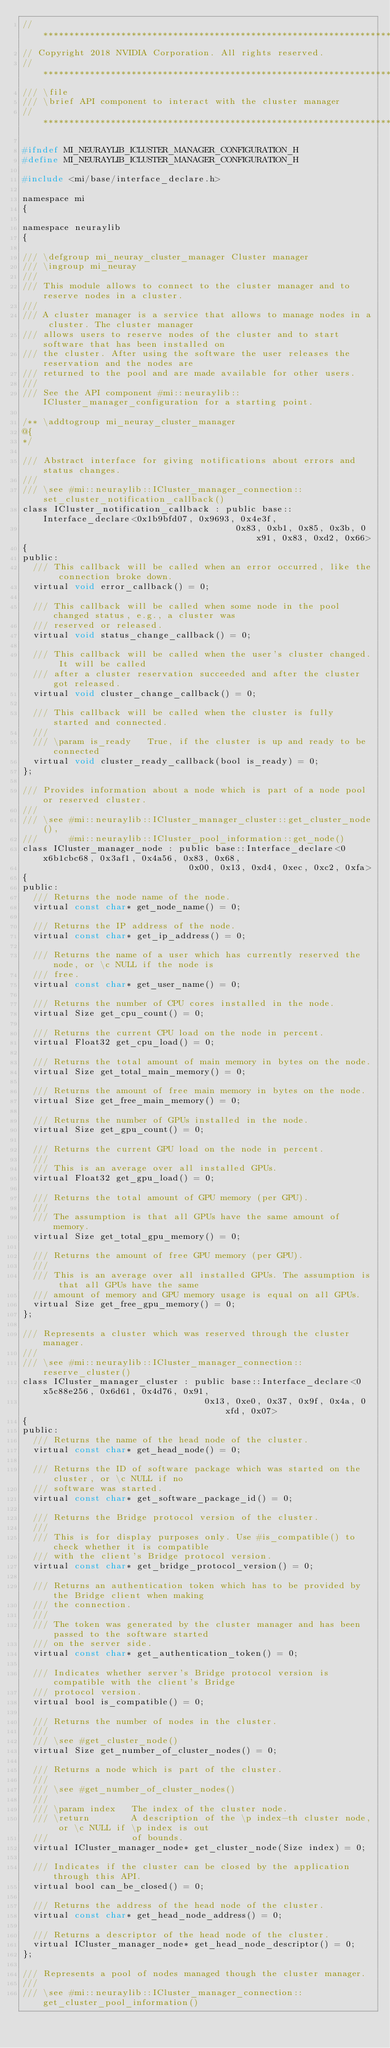Convert code to text. <code><loc_0><loc_0><loc_500><loc_500><_C_>//*****************************************************************************
// Copyright 2018 NVIDIA Corporation. All rights reserved.
//*****************************************************************************
/// \file
/// \brief API component to interact with the cluster manager
//*****************************************************************************

#ifndef MI_NEURAYLIB_ICLUSTER_MANAGER_CONFIGURATION_H
#define MI_NEURAYLIB_ICLUSTER_MANAGER_CONFIGURATION_H

#include <mi/base/interface_declare.h>

namespace mi
{

namespace neuraylib
{

/// \defgroup mi_neuray_cluster_manager Cluster manager
/// \ingroup mi_neuray
///
/// This module allows to connect to the cluster manager and to reserve nodes in a cluster.
///
/// A cluster manager is a service that allows to manage nodes in a cluster. The cluster manager
/// allows users to reserve nodes of the cluster and to start software that has been installed on
/// the cluster. After using the software the user releases the reservation and the nodes are
/// returned to the pool and are made available for other users.
///
/// See the API component #mi::neuraylib::ICluster_manager_configuration for a starting point.

/** \addtogroup mi_neuray_cluster_manager
@{
*/

/// Abstract interface for giving notifications about errors and status changes.
///
/// \see #mi::neuraylib::ICluster_manager_connection::set_cluster_notification_callback()
class ICluster_notification_callback : public base::Interface_declare<0x1b9bfd07, 0x9693, 0x4e3f,
                                         0x83, 0xb1, 0x85, 0x3b, 0x91, 0x83, 0xd2, 0x66>
{
public:
  /// This callback will be called when an error occurred, like the connection broke down.
  virtual void error_callback() = 0;

  /// This callback will be called when some node in the pool changed status, e.g., a cluster was
  /// reserved or released.
  virtual void status_change_callback() = 0;

  /// This callback will be called when the user's cluster changed. It will be called
  /// after a cluster reservation succeeded and after the cluster got released.
  virtual void cluster_change_callback() = 0;

  /// This callback will be called when the cluster is fully started and connected.
  ///
  /// \param is_ready   True, if the cluster is up and ready to be connected
  virtual void cluster_ready_callback(bool is_ready) = 0;
};

/// Provides information about a node which is part of a node pool or reserved cluster.
///
/// \see #mi::neuraylib::ICluster_manager_cluster::get_cluster_node(),
///      #mi::neuraylib::ICluster_pool_information::get_node()
class ICluster_manager_node : public base::Interface_declare<0x6b1cbc68, 0x3af1, 0x4a56, 0x83, 0x68,
                                0x00, 0x13, 0xd4, 0xec, 0xc2, 0xfa>
{
public:
  /// Returns the node name of the node.
  virtual const char* get_node_name() = 0;

  /// Returns the IP address of the node.
  virtual const char* get_ip_address() = 0;

  /// Returns the name of a user which has currently reserved the node, or \c NULL if the node is
  /// free.
  virtual const char* get_user_name() = 0;

  /// Returns the number of CPU cores installed in the node.
  virtual Size get_cpu_count() = 0;

  /// Returns the current CPU load on the node in percent.
  virtual Float32 get_cpu_load() = 0;

  /// Returns the total amount of main memory in bytes on the node.
  virtual Size get_total_main_memory() = 0;

  /// Returns the amount of free main memory in bytes on the node.
  virtual Size get_free_main_memory() = 0;

  /// Returns the number of GPUs installed in the node.
  virtual Size get_gpu_count() = 0;

  /// Returns the current GPU load on the node in percent.
  ///
  /// This is an average over all installed GPUs.
  virtual Float32 get_gpu_load() = 0;

  /// Returns the total amount of GPU memory (per GPU).
  ///
  /// The assumption is that all GPUs have the same amount of memory.
  virtual Size get_total_gpu_memory() = 0;

  /// Returns the amount of free GPU memory (per GPU).
  ///
  /// This is an average over all installed GPUs. The assumption is that all GPUs have the same
  /// amount of memory and GPU memory usage is equal on all GPUs.
  virtual Size get_free_gpu_memory() = 0;
};

/// Represents a cluster which was reserved through the cluster manager.
///
/// \see #mi::neuraylib::ICluster_manager_connection::reserve_cluster()
class ICluster_manager_cluster : public base::Interface_declare<0x5c88e256, 0x6d61, 0x4d76, 0x91,
                                   0x13, 0xe0, 0x37, 0x9f, 0x4a, 0xfd, 0x07>
{
public:
  /// Returns the name of the head node of the cluster.
  virtual const char* get_head_node() = 0;

  /// Returns the ID of software package which was started on the cluster, or \c NULL if no
  /// software was started.
  virtual const char* get_software_package_id() = 0;

  /// Returns the Bridge protocol version of the cluster.
  ///
  /// This is for display purposes only. Use #is_compatible() to check whether it is compatible
  /// with the client's Bridge protocol version.
  virtual const char* get_bridge_protocol_version() = 0;

  /// Returns an authentication token which has to be provided by the Bridge client when making
  /// the connection.
  ///
  /// The token was generated by the cluster manager and has been passed to the software started
  /// on the server side.
  virtual const char* get_authentication_token() = 0;

  /// Indicates whether server's Bridge protocol version is compatible with the client's Bridge
  /// protocol version.
  virtual bool is_compatible() = 0;

  /// Returns the number of nodes in the cluster.
  ///
  /// \see #get_cluster_node()
  virtual Size get_number_of_cluster_nodes() = 0;

  /// Returns a node which is part of the cluster.
  ///
  /// \see #get_number_of_cluster_nodes()
  ///
  /// \param index   The index of the cluster node.
  /// \return        A description of the \p index-th cluster node, or \c NULL if \p index is out
  ///                of bounds.
  virtual ICluster_manager_node* get_cluster_node(Size index) = 0;

  /// Indicates if the cluster can be closed by the application through this API.
  virtual bool can_be_closed() = 0;

  /// Returns the address of the head node of the cluster.
  virtual const char* get_head_node_address() = 0;

  /// Returns a descriptor of the head node of the cluster.
  virtual ICluster_manager_node* get_head_node_descriptor() = 0;
};

/// Represents a pool of nodes managed though the cluster manager.
///
/// \see #mi::neuraylib::ICluster_manager_connection::get_cluster_pool_information()</code> 